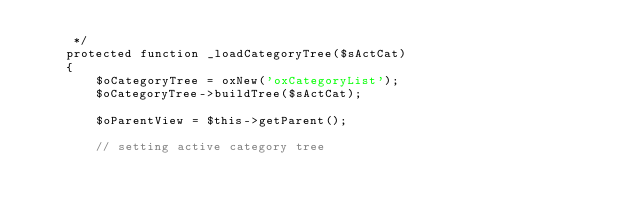<code> <loc_0><loc_0><loc_500><loc_500><_PHP_>     */
    protected function _loadCategoryTree($sActCat)
    {
        $oCategoryTree = oxNew('oxCategoryList');
        $oCategoryTree->buildTree($sActCat);

        $oParentView = $this->getParent();

        // setting active category tree</code> 